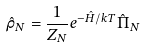<formula> <loc_0><loc_0><loc_500><loc_500>\hat { \rho } _ { N } = \frac { 1 } { Z _ { N } } e ^ { - \hat { H } / k T } \hat { \Pi } _ { N }</formula> 